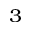<formula> <loc_0><loc_0><loc_500><loc_500>_ { 3 }</formula> 